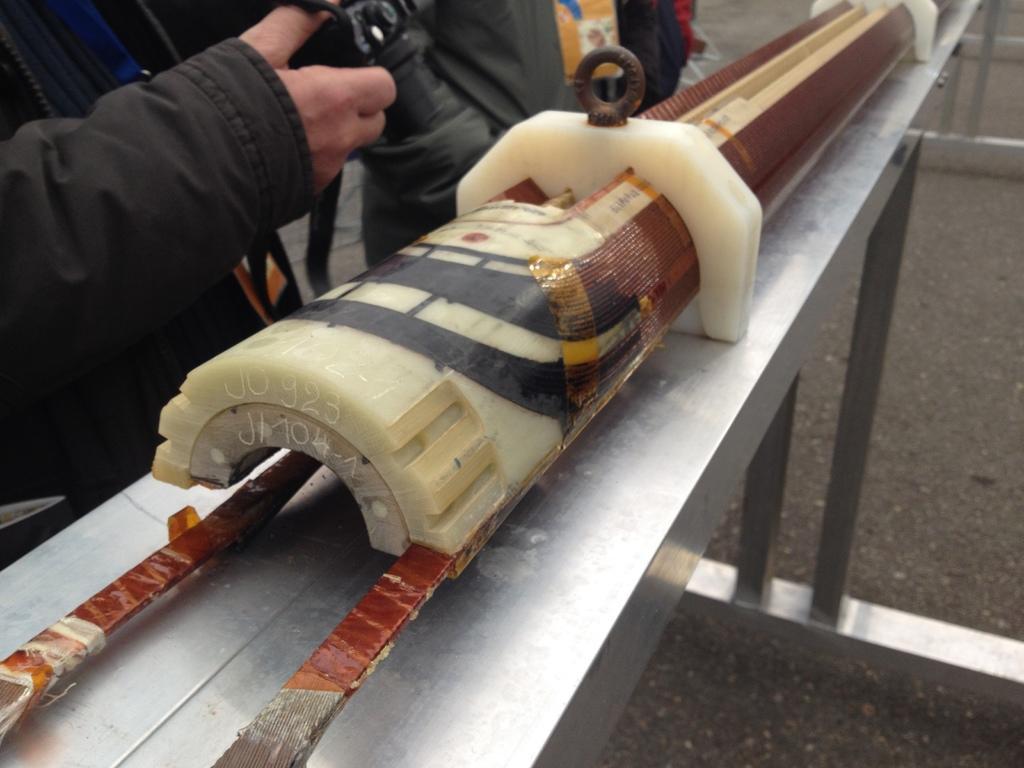Please provide a concise description of this image. Here in this picture we can see an equipment present on a table and beside that we can see people standing. 